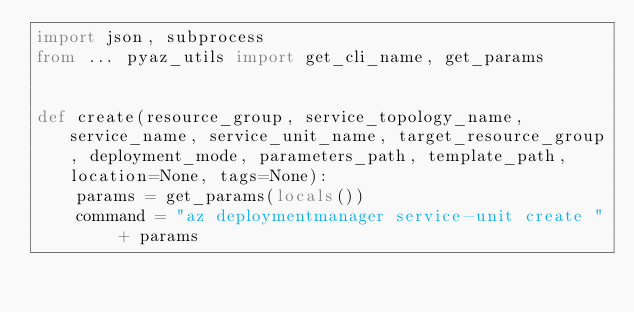<code> <loc_0><loc_0><loc_500><loc_500><_Python_>import json, subprocess
from ... pyaz_utils import get_cli_name, get_params


def create(resource_group, service_topology_name, service_name, service_unit_name, target_resource_group, deployment_mode, parameters_path, template_path, location=None, tags=None):
    params = get_params(locals())   
    command = "az deploymentmanager service-unit create " + params</code> 